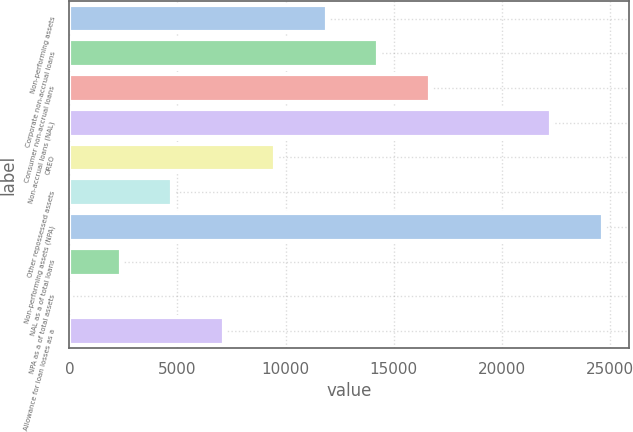Convert chart. <chart><loc_0><loc_0><loc_500><loc_500><bar_chart><fcel>Non-performing assets<fcel>Corporate non-accrual loans<fcel>Consumer non-accrual loans<fcel>Non-accrual loans (NAL)<fcel>OREO<fcel>Other repossessed assets<fcel>Non-performing assets (NPA)<fcel>NAL as a of total loans<fcel>NPA as a of total assets<fcel>Allowance for loan losses as a<nl><fcel>11904.6<fcel>14285.3<fcel>16666<fcel>22297<fcel>9523.94<fcel>4762.58<fcel>24677.7<fcel>2381.9<fcel>1.22<fcel>7143.26<nl></chart> 